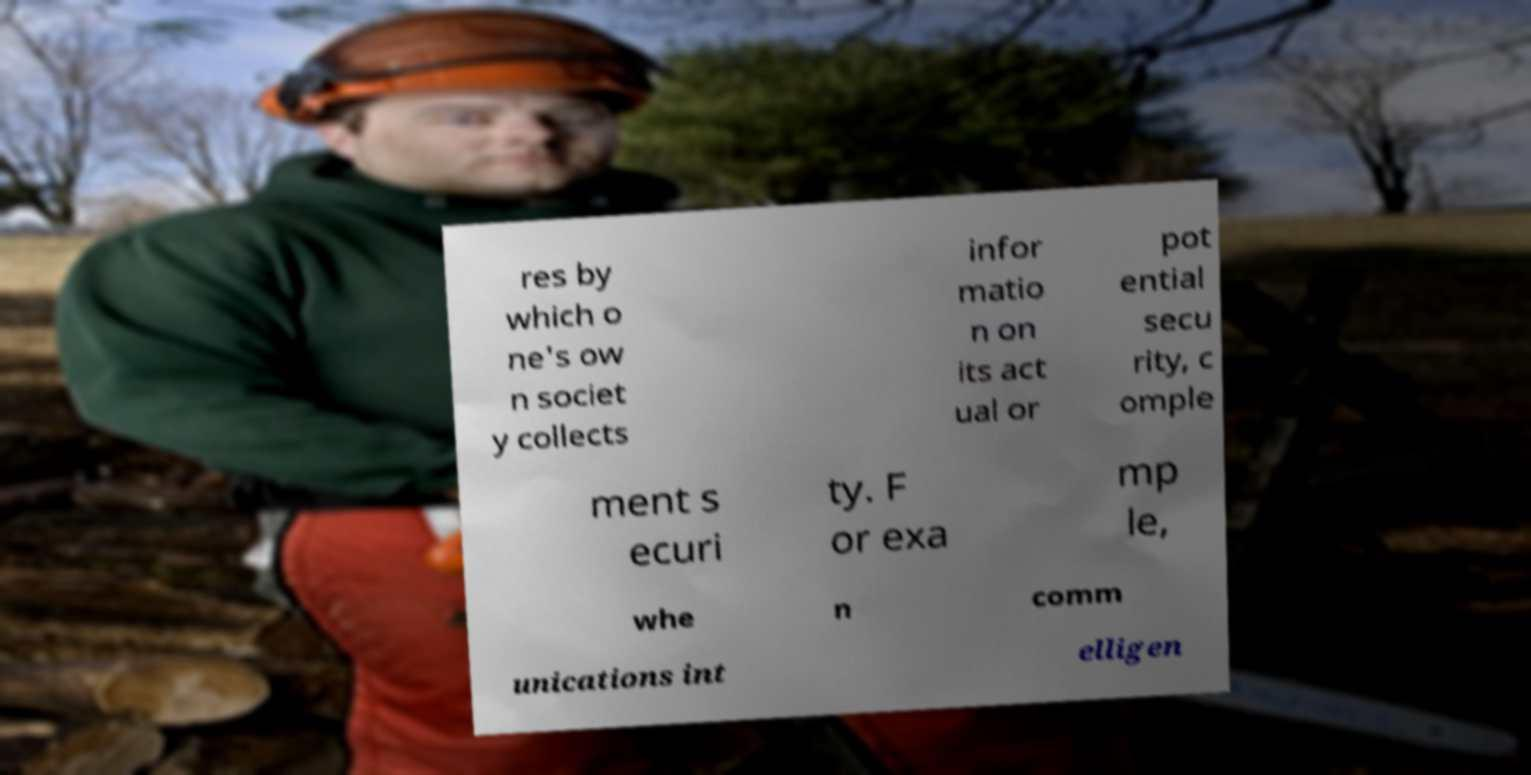There's text embedded in this image that I need extracted. Can you transcribe it verbatim? res by which o ne's ow n societ y collects infor matio n on its act ual or pot ential secu rity, c omple ment s ecuri ty. F or exa mp le, whe n comm unications int elligen 